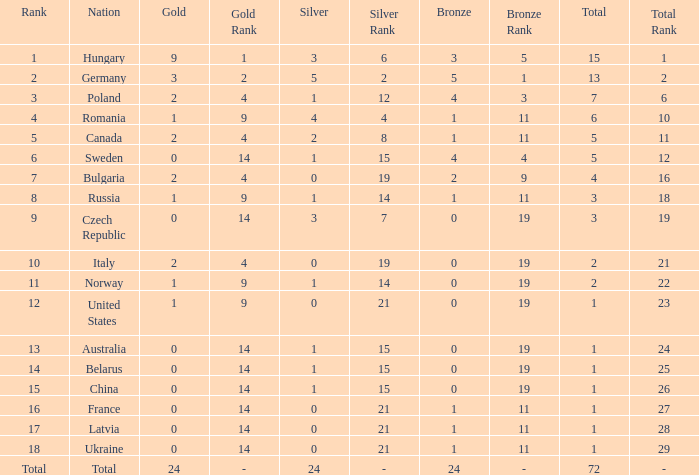Could you parse the entire table as a dict? {'header': ['Rank', 'Nation', 'Gold', 'Gold Rank', 'Silver', 'Silver Rank', 'Bronze', 'Bronze Rank', 'Total', 'Total Rank'], 'rows': [['1', 'Hungary', '9', '1', '3', '6', '3', '5', '15', '1'], ['2', 'Germany', '3', '2', '5', '2', '5', '1', '13', '2'], ['3', 'Poland', '2', '4', '1', '12', '4', '3', '7', '6'], ['4', 'Romania', '1', '9', '4', '4', '1', '11', '6', '10'], ['5', 'Canada', '2', '4', '2', '8', '1', '11', '5', '11'], ['6', 'Sweden', '0', '14', '1', '15', '4', '4', '5', '12'], ['7', 'Bulgaria', '2', '4', '0', '19', '2', '9', '4', '16'], ['8', 'Russia', '1', '9', '1', '14', '1', '11', '3', '18'], ['9', 'Czech Republic', '0', '14', '3', '7', '0', '19', '3', '19'], ['10', 'Italy', '2', '4', '0', '19', '0', '19', '2', '21'], ['11', 'Norway', '1', '9', '1', '14', '0', '19', '2', '22'], ['12', 'United States', '1', '9', '0', '21', '0', '19', '1', '23'], ['13', 'Australia', '0', '14', '1', '15', '0', '19', '1', '24'], ['14', 'Belarus', '0', '14', '1', '15', '0', '19', '1', '25'], ['15', 'China', '0', '14', '1', '15', '0', '19', '1', '26'], ['16', 'France', '0', '14', '0', '21', '1', '11', '1', '27'], ['17', 'Latvia', '0', '14', '0', '21', '1', '11', '1', '28'], ['18', 'Ukraine', '0', '14', '0', '21', '1', '11', '1', '29'], ['Total', 'Total', '24', '-', '24', '-', '24', '-', '72', '-']]} How many golds have 3 as the rank, with a total greater than 7? 0.0. 